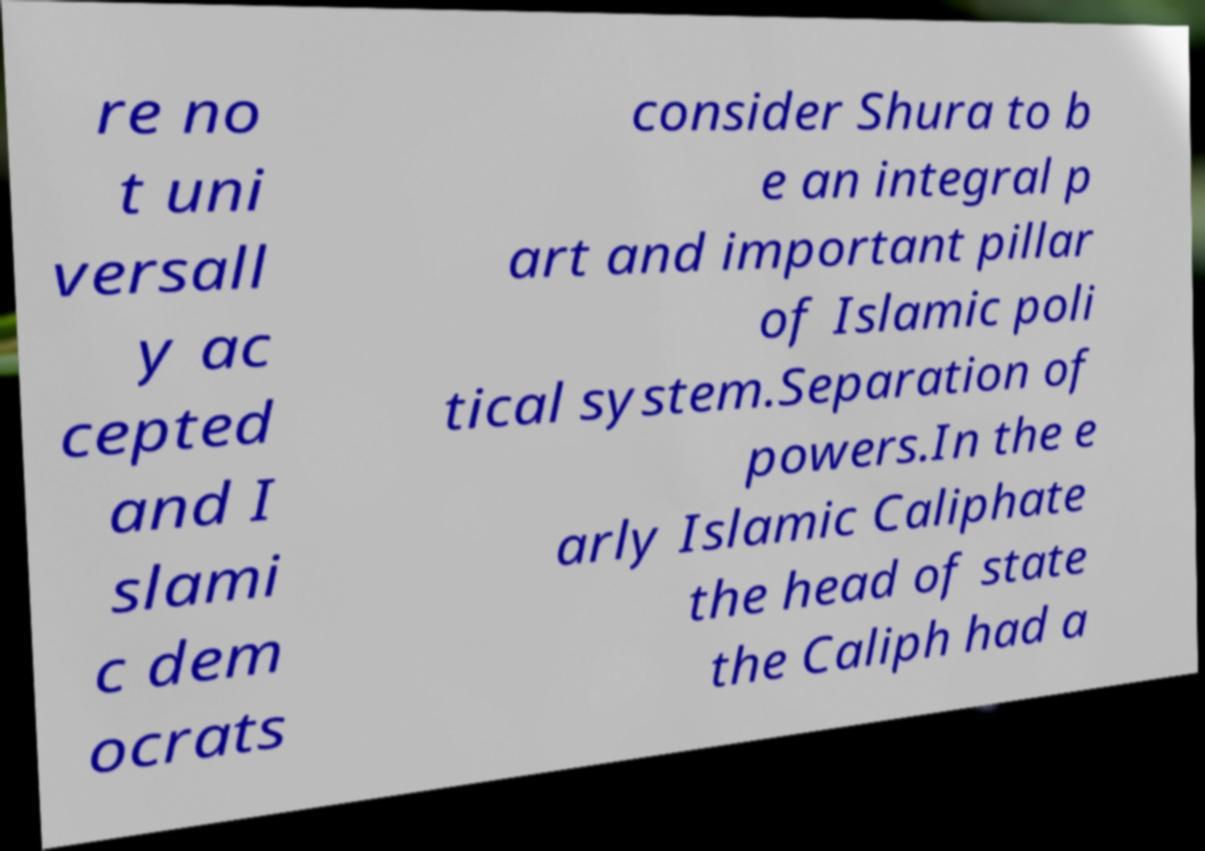Please read and relay the text visible in this image. What does it say? re no t uni versall y ac cepted and I slami c dem ocrats consider Shura to b e an integral p art and important pillar of Islamic poli tical system.Separation of powers.In the e arly Islamic Caliphate the head of state the Caliph had a 